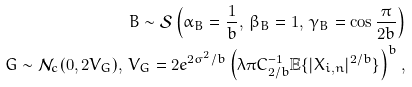Convert formula to latex. <formula><loc_0><loc_0><loc_500><loc_500>B \sim \mathcal { S } \left ( \alpha _ { B } = \frac { 1 } { b } , \, \beta _ { B } = 1 , \, \gamma _ { B } = \cos \frac { \pi } { 2 b } \right ) \\ G \sim \mathcal { N } _ { c } ( 0 , 2 V _ { G } ) , \, V _ { G } = 2 e ^ { 2 \sigma ^ { 2 } / b } \left ( \lambda \pi C _ { 2 / b } ^ { - 1 } \mathbb { E } \{ | X _ { i , n } | ^ { 2 / b } \} \right ) ^ { b } ,</formula> 